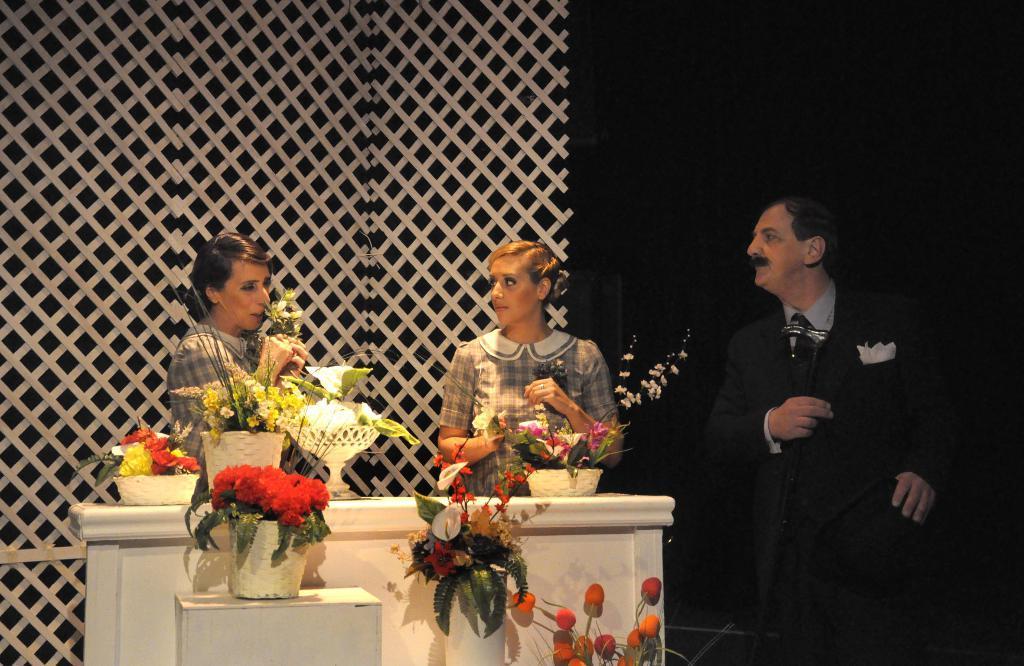Can you describe this image briefly? In this image we can see a group of people standing. One woman is holding leaves with her hands. In the foreground we can see some flowers and leaves placed in baskets and pots kept on the surface. In the background, we can see a fence. 